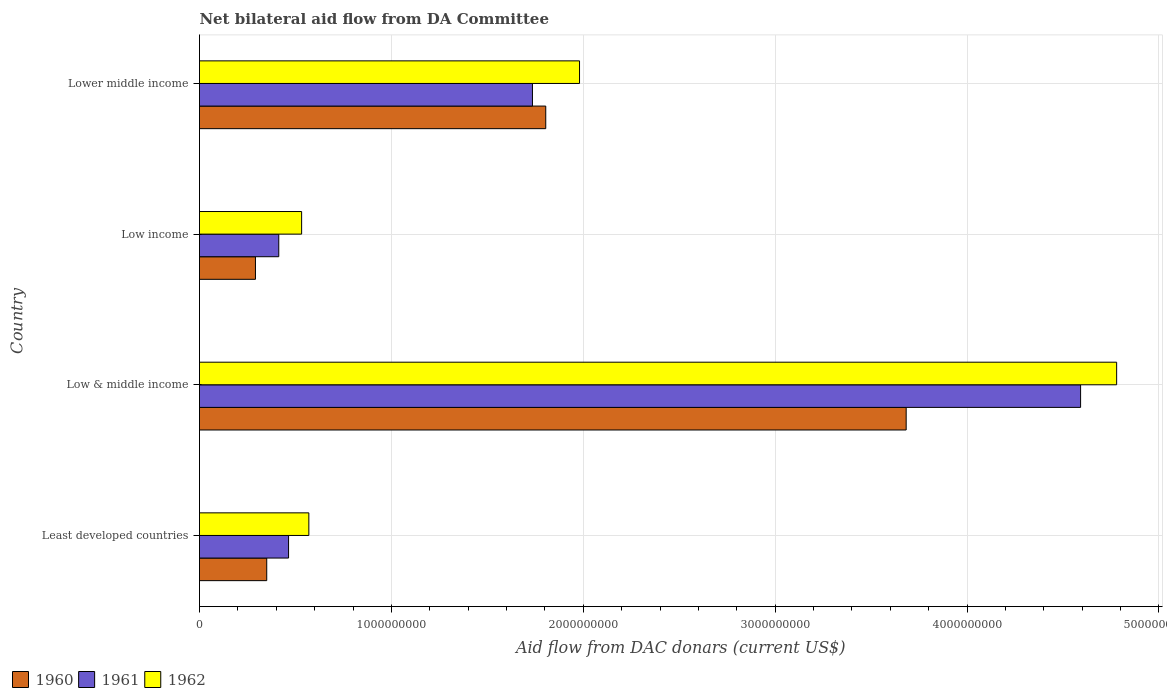Are the number of bars per tick equal to the number of legend labels?
Give a very brief answer. Yes. Are the number of bars on each tick of the Y-axis equal?
Your response must be concise. Yes. How many bars are there on the 1st tick from the top?
Provide a succinct answer. 3. How many bars are there on the 4th tick from the bottom?
Offer a very short reply. 3. What is the label of the 2nd group of bars from the top?
Provide a succinct answer. Low income. In how many cases, is the number of bars for a given country not equal to the number of legend labels?
Provide a succinct answer. 0. What is the aid flow in in 1960 in Low income?
Your response must be concise. 2.92e+08. Across all countries, what is the maximum aid flow in in 1961?
Provide a short and direct response. 4.59e+09. Across all countries, what is the minimum aid flow in in 1961?
Give a very brief answer. 4.13e+08. In which country was the aid flow in in 1960 maximum?
Your answer should be compact. Low & middle income. In which country was the aid flow in in 1962 minimum?
Provide a short and direct response. Low income. What is the total aid flow in in 1961 in the graph?
Your answer should be compact. 7.20e+09. What is the difference between the aid flow in in 1960 in Low income and that in Lower middle income?
Give a very brief answer. -1.51e+09. What is the difference between the aid flow in in 1962 in Lower middle income and the aid flow in in 1961 in Low & middle income?
Provide a short and direct response. -2.61e+09. What is the average aid flow in in 1960 per country?
Your answer should be compact. 1.53e+09. What is the difference between the aid flow in in 1961 and aid flow in in 1962 in Least developed countries?
Your response must be concise. -1.06e+08. In how many countries, is the aid flow in in 1961 greater than 3800000000 US$?
Make the answer very short. 1. What is the ratio of the aid flow in in 1960 in Low income to that in Lower middle income?
Your answer should be very brief. 0.16. Is the aid flow in in 1961 in Low income less than that in Lower middle income?
Keep it short and to the point. Yes. Is the difference between the aid flow in in 1961 in Least developed countries and Lower middle income greater than the difference between the aid flow in in 1962 in Least developed countries and Lower middle income?
Your answer should be compact. Yes. What is the difference between the highest and the second highest aid flow in in 1960?
Your response must be concise. 1.88e+09. What is the difference between the highest and the lowest aid flow in in 1960?
Your answer should be compact. 3.39e+09. In how many countries, is the aid flow in in 1962 greater than the average aid flow in in 1962 taken over all countries?
Make the answer very short. 2. Is the sum of the aid flow in in 1960 in Low & middle income and Lower middle income greater than the maximum aid flow in in 1962 across all countries?
Your answer should be compact. Yes. What does the 2nd bar from the bottom in Least developed countries represents?
Your response must be concise. 1961. How many bars are there?
Offer a very short reply. 12. Are all the bars in the graph horizontal?
Offer a very short reply. Yes. How many countries are there in the graph?
Provide a short and direct response. 4. What is the difference between two consecutive major ticks on the X-axis?
Give a very brief answer. 1.00e+09. Does the graph contain grids?
Make the answer very short. Yes. Where does the legend appear in the graph?
Provide a short and direct response. Bottom left. How are the legend labels stacked?
Provide a succinct answer. Horizontal. What is the title of the graph?
Keep it short and to the point. Net bilateral aid flow from DA Committee. What is the label or title of the X-axis?
Give a very brief answer. Aid flow from DAC donars (current US$). What is the Aid flow from DAC donars (current US$) in 1960 in Least developed countries?
Keep it short and to the point. 3.50e+08. What is the Aid flow from DAC donars (current US$) of 1961 in Least developed countries?
Your answer should be very brief. 4.64e+08. What is the Aid flow from DAC donars (current US$) in 1962 in Least developed countries?
Your answer should be very brief. 5.70e+08. What is the Aid flow from DAC donars (current US$) of 1960 in Low & middle income?
Your answer should be very brief. 3.68e+09. What is the Aid flow from DAC donars (current US$) of 1961 in Low & middle income?
Your answer should be very brief. 4.59e+09. What is the Aid flow from DAC donars (current US$) of 1962 in Low & middle income?
Offer a very short reply. 4.78e+09. What is the Aid flow from DAC donars (current US$) of 1960 in Low income?
Your answer should be very brief. 2.92e+08. What is the Aid flow from DAC donars (current US$) in 1961 in Low income?
Provide a short and direct response. 4.13e+08. What is the Aid flow from DAC donars (current US$) of 1962 in Low income?
Keep it short and to the point. 5.32e+08. What is the Aid flow from DAC donars (current US$) in 1960 in Lower middle income?
Your answer should be compact. 1.80e+09. What is the Aid flow from DAC donars (current US$) of 1961 in Lower middle income?
Give a very brief answer. 1.74e+09. What is the Aid flow from DAC donars (current US$) of 1962 in Lower middle income?
Your response must be concise. 1.98e+09. Across all countries, what is the maximum Aid flow from DAC donars (current US$) in 1960?
Provide a short and direct response. 3.68e+09. Across all countries, what is the maximum Aid flow from DAC donars (current US$) of 1961?
Make the answer very short. 4.59e+09. Across all countries, what is the maximum Aid flow from DAC donars (current US$) of 1962?
Make the answer very short. 4.78e+09. Across all countries, what is the minimum Aid flow from DAC donars (current US$) in 1960?
Offer a terse response. 2.92e+08. Across all countries, what is the minimum Aid flow from DAC donars (current US$) in 1961?
Offer a very short reply. 4.13e+08. Across all countries, what is the minimum Aid flow from DAC donars (current US$) of 1962?
Make the answer very short. 5.32e+08. What is the total Aid flow from DAC donars (current US$) in 1960 in the graph?
Provide a short and direct response. 6.13e+09. What is the total Aid flow from DAC donars (current US$) of 1961 in the graph?
Your answer should be compact. 7.20e+09. What is the total Aid flow from DAC donars (current US$) of 1962 in the graph?
Provide a succinct answer. 7.86e+09. What is the difference between the Aid flow from DAC donars (current US$) of 1960 in Least developed countries and that in Low & middle income?
Your answer should be compact. -3.33e+09. What is the difference between the Aid flow from DAC donars (current US$) in 1961 in Least developed countries and that in Low & middle income?
Provide a short and direct response. -4.13e+09. What is the difference between the Aid flow from DAC donars (current US$) of 1962 in Least developed countries and that in Low & middle income?
Offer a very short reply. -4.21e+09. What is the difference between the Aid flow from DAC donars (current US$) in 1960 in Least developed countries and that in Low income?
Offer a terse response. 5.88e+07. What is the difference between the Aid flow from DAC donars (current US$) in 1961 in Least developed countries and that in Low income?
Your answer should be very brief. 5.11e+07. What is the difference between the Aid flow from DAC donars (current US$) of 1962 in Least developed countries and that in Low income?
Your answer should be compact. 3.76e+07. What is the difference between the Aid flow from DAC donars (current US$) in 1960 in Least developed countries and that in Lower middle income?
Offer a very short reply. -1.45e+09. What is the difference between the Aid flow from DAC donars (current US$) of 1961 in Least developed countries and that in Lower middle income?
Keep it short and to the point. -1.27e+09. What is the difference between the Aid flow from DAC donars (current US$) of 1962 in Least developed countries and that in Lower middle income?
Offer a very short reply. -1.41e+09. What is the difference between the Aid flow from DAC donars (current US$) in 1960 in Low & middle income and that in Low income?
Keep it short and to the point. 3.39e+09. What is the difference between the Aid flow from DAC donars (current US$) of 1961 in Low & middle income and that in Low income?
Provide a short and direct response. 4.18e+09. What is the difference between the Aid flow from DAC donars (current US$) of 1962 in Low & middle income and that in Low income?
Your response must be concise. 4.25e+09. What is the difference between the Aid flow from DAC donars (current US$) of 1960 in Low & middle income and that in Lower middle income?
Your answer should be compact. 1.88e+09. What is the difference between the Aid flow from DAC donars (current US$) of 1961 in Low & middle income and that in Lower middle income?
Give a very brief answer. 2.86e+09. What is the difference between the Aid flow from DAC donars (current US$) in 1962 in Low & middle income and that in Lower middle income?
Offer a terse response. 2.80e+09. What is the difference between the Aid flow from DAC donars (current US$) of 1960 in Low income and that in Lower middle income?
Offer a terse response. -1.51e+09. What is the difference between the Aid flow from DAC donars (current US$) of 1961 in Low income and that in Lower middle income?
Keep it short and to the point. -1.32e+09. What is the difference between the Aid flow from DAC donars (current US$) of 1962 in Low income and that in Lower middle income?
Your response must be concise. -1.45e+09. What is the difference between the Aid flow from DAC donars (current US$) in 1960 in Least developed countries and the Aid flow from DAC donars (current US$) in 1961 in Low & middle income?
Offer a very short reply. -4.24e+09. What is the difference between the Aid flow from DAC donars (current US$) in 1960 in Least developed countries and the Aid flow from DAC donars (current US$) in 1962 in Low & middle income?
Your response must be concise. -4.43e+09. What is the difference between the Aid flow from DAC donars (current US$) of 1961 in Least developed countries and the Aid flow from DAC donars (current US$) of 1962 in Low & middle income?
Your answer should be very brief. -4.32e+09. What is the difference between the Aid flow from DAC donars (current US$) in 1960 in Least developed countries and the Aid flow from DAC donars (current US$) in 1961 in Low income?
Your answer should be very brief. -6.27e+07. What is the difference between the Aid flow from DAC donars (current US$) of 1960 in Least developed countries and the Aid flow from DAC donars (current US$) of 1962 in Low income?
Keep it short and to the point. -1.82e+08. What is the difference between the Aid flow from DAC donars (current US$) in 1961 in Least developed countries and the Aid flow from DAC donars (current US$) in 1962 in Low income?
Ensure brevity in your answer.  -6.81e+07. What is the difference between the Aid flow from DAC donars (current US$) in 1960 in Least developed countries and the Aid flow from DAC donars (current US$) in 1961 in Lower middle income?
Offer a terse response. -1.38e+09. What is the difference between the Aid flow from DAC donars (current US$) in 1960 in Least developed countries and the Aid flow from DAC donars (current US$) in 1962 in Lower middle income?
Ensure brevity in your answer.  -1.63e+09. What is the difference between the Aid flow from DAC donars (current US$) in 1961 in Least developed countries and the Aid flow from DAC donars (current US$) in 1962 in Lower middle income?
Provide a succinct answer. -1.52e+09. What is the difference between the Aid flow from DAC donars (current US$) of 1960 in Low & middle income and the Aid flow from DAC donars (current US$) of 1961 in Low income?
Make the answer very short. 3.27e+09. What is the difference between the Aid flow from DAC donars (current US$) in 1960 in Low & middle income and the Aid flow from DAC donars (current US$) in 1962 in Low income?
Offer a very short reply. 3.15e+09. What is the difference between the Aid flow from DAC donars (current US$) in 1961 in Low & middle income and the Aid flow from DAC donars (current US$) in 1962 in Low income?
Provide a succinct answer. 4.06e+09. What is the difference between the Aid flow from DAC donars (current US$) in 1960 in Low & middle income and the Aid flow from DAC donars (current US$) in 1961 in Lower middle income?
Give a very brief answer. 1.95e+09. What is the difference between the Aid flow from DAC donars (current US$) of 1960 in Low & middle income and the Aid flow from DAC donars (current US$) of 1962 in Lower middle income?
Your answer should be very brief. 1.70e+09. What is the difference between the Aid flow from DAC donars (current US$) in 1961 in Low & middle income and the Aid flow from DAC donars (current US$) in 1962 in Lower middle income?
Offer a terse response. 2.61e+09. What is the difference between the Aid flow from DAC donars (current US$) in 1960 in Low income and the Aid flow from DAC donars (current US$) in 1961 in Lower middle income?
Ensure brevity in your answer.  -1.44e+09. What is the difference between the Aid flow from DAC donars (current US$) in 1960 in Low income and the Aid flow from DAC donars (current US$) in 1962 in Lower middle income?
Your response must be concise. -1.69e+09. What is the difference between the Aid flow from DAC donars (current US$) in 1961 in Low income and the Aid flow from DAC donars (current US$) in 1962 in Lower middle income?
Ensure brevity in your answer.  -1.57e+09. What is the average Aid flow from DAC donars (current US$) of 1960 per country?
Give a very brief answer. 1.53e+09. What is the average Aid flow from DAC donars (current US$) of 1961 per country?
Your answer should be compact. 1.80e+09. What is the average Aid flow from DAC donars (current US$) of 1962 per country?
Ensure brevity in your answer.  1.97e+09. What is the difference between the Aid flow from DAC donars (current US$) in 1960 and Aid flow from DAC donars (current US$) in 1961 in Least developed countries?
Offer a terse response. -1.14e+08. What is the difference between the Aid flow from DAC donars (current US$) of 1960 and Aid flow from DAC donars (current US$) of 1962 in Least developed countries?
Provide a short and direct response. -2.19e+08. What is the difference between the Aid flow from DAC donars (current US$) in 1961 and Aid flow from DAC donars (current US$) in 1962 in Least developed countries?
Offer a terse response. -1.06e+08. What is the difference between the Aid flow from DAC donars (current US$) in 1960 and Aid flow from DAC donars (current US$) in 1961 in Low & middle income?
Make the answer very short. -9.09e+08. What is the difference between the Aid flow from DAC donars (current US$) of 1960 and Aid flow from DAC donars (current US$) of 1962 in Low & middle income?
Give a very brief answer. -1.10e+09. What is the difference between the Aid flow from DAC donars (current US$) of 1961 and Aid flow from DAC donars (current US$) of 1962 in Low & middle income?
Your answer should be compact. -1.88e+08. What is the difference between the Aid flow from DAC donars (current US$) in 1960 and Aid flow from DAC donars (current US$) in 1961 in Low income?
Provide a short and direct response. -1.21e+08. What is the difference between the Aid flow from DAC donars (current US$) of 1960 and Aid flow from DAC donars (current US$) of 1962 in Low income?
Provide a succinct answer. -2.41e+08. What is the difference between the Aid flow from DAC donars (current US$) in 1961 and Aid flow from DAC donars (current US$) in 1962 in Low income?
Offer a terse response. -1.19e+08. What is the difference between the Aid flow from DAC donars (current US$) in 1960 and Aid flow from DAC donars (current US$) in 1961 in Lower middle income?
Keep it short and to the point. 6.93e+07. What is the difference between the Aid flow from DAC donars (current US$) of 1960 and Aid flow from DAC donars (current US$) of 1962 in Lower middle income?
Provide a short and direct response. -1.76e+08. What is the difference between the Aid flow from DAC donars (current US$) of 1961 and Aid flow from DAC donars (current US$) of 1962 in Lower middle income?
Provide a succinct answer. -2.45e+08. What is the ratio of the Aid flow from DAC donars (current US$) of 1960 in Least developed countries to that in Low & middle income?
Make the answer very short. 0.1. What is the ratio of the Aid flow from DAC donars (current US$) of 1961 in Least developed countries to that in Low & middle income?
Give a very brief answer. 0.1. What is the ratio of the Aid flow from DAC donars (current US$) in 1962 in Least developed countries to that in Low & middle income?
Provide a succinct answer. 0.12. What is the ratio of the Aid flow from DAC donars (current US$) of 1960 in Least developed countries to that in Low income?
Make the answer very short. 1.2. What is the ratio of the Aid flow from DAC donars (current US$) of 1961 in Least developed countries to that in Low income?
Provide a succinct answer. 1.12. What is the ratio of the Aid flow from DAC donars (current US$) of 1962 in Least developed countries to that in Low income?
Make the answer very short. 1.07. What is the ratio of the Aid flow from DAC donars (current US$) of 1960 in Least developed countries to that in Lower middle income?
Ensure brevity in your answer.  0.19. What is the ratio of the Aid flow from DAC donars (current US$) in 1961 in Least developed countries to that in Lower middle income?
Make the answer very short. 0.27. What is the ratio of the Aid flow from DAC donars (current US$) in 1962 in Least developed countries to that in Lower middle income?
Ensure brevity in your answer.  0.29. What is the ratio of the Aid flow from DAC donars (current US$) of 1960 in Low & middle income to that in Low income?
Ensure brevity in your answer.  12.63. What is the ratio of the Aid flow from DAC donars (current US$) of 1961 in Low & middle income to that in Low income?
Offer a terse response. 11.12. What is the ratio of the Aid flow from DAC donars (current US$) of 1962 in Low & middle income to that in Low income?
Ensure brevity in your answer.  8.98. What is the ratio of the Aid flow from DAC donars (current US$) of 1960 in Low & middle income to that in Lower middle income?
Make the answer very short. 2.04. What is the ratio of the Aid flow from DAC donars (current US$) in 1961 in Low & middle income to that in Lower middle income?
Make the answer very short. 2.65. What is the ratio of the Aid flow from DAC donars (current US$) in 1962 in Low & middle income to that in Lower middle income?
Offer a terse response. 2.41. What is the ratio of the Aid flow from DAC donars (current US$) in 1960 in Low income to that in Lower middle income?
Make the answer very short. 0.16. What is the ratio of the Aid flow from DAC donars (current US$) in 1961 in Low income to that in Lower middle income?
Offer a terse response. 0.24. What is the ratio of the Aid flow from DAC donars (current US$) in 1962 in Low income to that in Lower middle income?
Offer a terse response. 0.27. What is the difference between the highest and the second highest Aid flow from DAC donars (current US$) in 1960?
Offer a very short reply. 1.88e+09. What is the difference between the highest and the second highest Aid flow from DAC donars (current US$) of 1961?
Provide a succinct answer. 2.86e+09. What is the difference between the highest and the second highest Aid flow from DAC donars (current US$) of 1962?
Provide a succinct answer. 2.80e+09. What is the difference between the highest and the lowest Aid flow from DAC donars (current US$) in 1960?
Your answer should be compact. 3.39e+09. What is the difference between the highest and the lowest Aid flow from DAC donars (current US$) of 1961?
Provide a short and direct response. 4.18e+09. What is the difference between the highest and the lowest Aid flow from DAC donars (current US$) of 1962?
Your answer should be compact. 4.25e+09. 